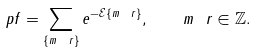Convert formula to latex. <formula><loc_0><loc_0><loc_500><loc_500>\ p f = \sum _ { \{ m _ { \ } r \} } e ^ { - \mathcal { E } \{ m _ { \ } r \} } , \quad m _ { \ } r \in \mathbb { Z } .</formula> 